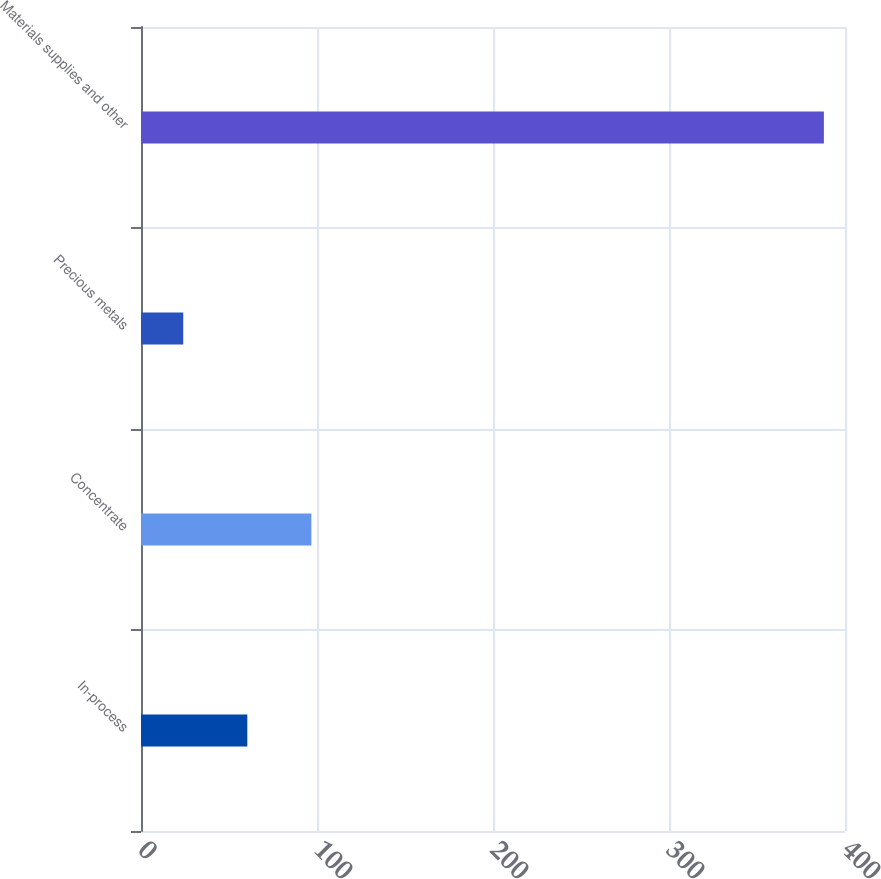<chart> <loc_0><loc_0><loc_500><loc_500><bar_chart><fcel>In-process<fcel>Concentrate<fcel>Precious metals<fcel>Materials supplies and other<nl><fcel>60.4<fcel>96.8<fcel>24<fcel>388<nl></chart> 